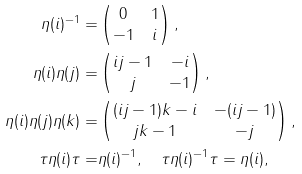Convert formula to latex. <formula><loc_0><loc_0><loc_500><loc_500>\eta ( i ) ^ { - 1 } = & \begin{pmatrix} 0 & 1 \\ - 1 & i \end{pmatrix} , \\ \eta ( i ) \eta ( j ) = & \begin{pmatrix} i j - 1 & - i \\ j & - 1 \end{pmatrix} , \\ \eta ( i ) \eta ( j ) \eta ( k ) = & \begin{pmatrix} ( i j - 1 ) k - i & - ( i j - 1 ) \\ j k - 1 & - j \end{pmatrix} , \\ \tau \eta ( i ) \tau = & \eta ( i ) ^ { - 1 } , \quad \tau \eta ( i ) ^ { - 1 } \tau = \eta ( i ) ,</formula> 